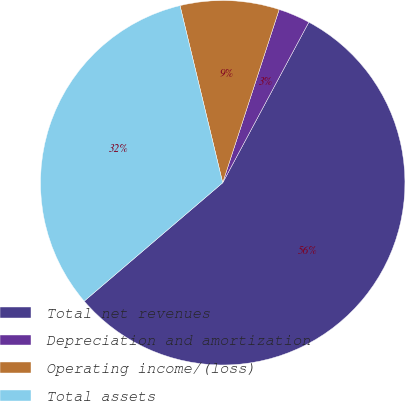<chart> <loc_0><loc_0><loc_500><loc_500><pie_chart><fcel>Total net revenues<fcel>Depreciation and amortization<fcel>Operating income/(loss)<fcel>Total assets<nl><fcel>55.91%<fcel>2.82%<fcel>8.78%<fcel>32.49%<nl></chart> 